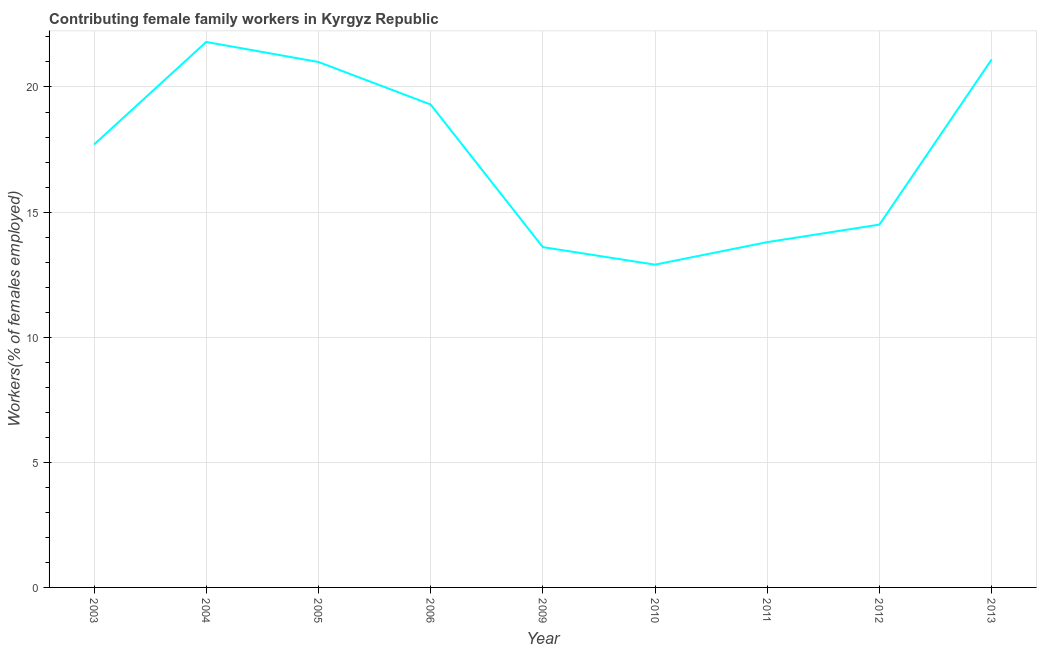What is the contributing female family workers in 2013?
Offer a terse response. 21.1. Across all years, what is the maximum contributing female family workers?
Keep it short and to the point. 21.8. Across all years, what is the minimum contributing female family workers?
Your answer should be very brief. 12.9. In which year was the contributing female family workers minimum?
Ensure brevity in your answer.  2010. What is the sum of the contributing female family workers?
Your answer should be very brief. 155.7. What is the difference between the contributing female family workers in 2006 and 2010?
Keep it short and to the point. 6.4. What is the average contributing female family workers per year?
Provide a succinct answer. 17.3. What is the median contributing female family workers?
Offer a terse response. 17.7. In how many years, is the contributing female family workers greater than 4 %?
Keep it short and to the point. 9. Do a majority of the years between 2012 and 2005 (inclusive) have contributing female family workers greater than 11 %?
Offer a very short reply. Yes. What is the ratio of the contributing female family workers in 2003 to that in 2005?
Offer a terse response. 0.84. Is the contributing female family workers in 2003 less than that in 2004?
Provide a short and direct response. Yes. What is the difference between the highest and the second highest contributing female family workers?
Make the answer very short. 0.7. Is the sum of the contributing female family workers in 2005 and 2010 greater than the maximum contributing female family workers across all years?
Provide a short and direct response. Yes. What is the difference between the highest and the lowest contributing female family workers?
Offer a terse response. 8.9. Does the contributing female family workers monotonically increase over the years?
Provide a succinct answer. No. How many years are there in the graph?
Provide a short and direct response. 9. Are the values on the major ticks of Y-axis written in scientific E-notation?
Offer a very short reply. No. Does the graph contain grids?
Ensure brevity in your answer.  Yes. What is the title of the graph?
Offer a very short reply. Contributing female family workers in Kyrgyz Republic. What is the label or title of the X-axis?
Give a very brief answer. Year. What is the label or title of the Y-axis?
Provide a succinct answer. Workers(% of females employed). What is the Workers(% of females employed) of 2003?
Provide a succinct answer. 17.7. What is the Workers(% of females employed) in 2004?
Offer a very short reply. 21.8. What is the Workers(% of females employed) of 2005?
Keep it short and to the point. 21. What is the Workers(% of females employed) of 2006?
Your answer should be very brief. 19.3. What is the Workers(% of females employed) of 2009?
Provide a short and direct response. 13.6. What is the Workers(% of females employed) in 2010?
Your answer should be compact. 12.9. What is the Workers(% of females employed) of 2011?
Give a very brief answer. 13.8. What is the Workers(% of females employed) in 2012?
Provide a succinct answer. 14.5. What is the Workers(% of females employed) of 2013?
Your answer should be very brief. 21.1. What is the difference between the Workers(% of females employed) in 2003 and 2004?
Offer a very short reply. -4.1. What is the difference between the Workers(% of females employed) in 2003 and 2005?
Provide a short and direct response. -3.3. What is the difference between the Workers(% of females employed) in 2003 and 2012?
Provide a short and direct response. 3.2. What is the difference between the Workers(% of females employed) in 2003 and 2013?
Offer a very short reply. -3.4. What is the difference between the Workers(% of females employed) in 2004 and 2005?
Provide a succinct answer. 0.8. What is the difference between the Workers(% of females employed) in 2004 and 2006?
Keep it short and to the point. 2.5. What is the difference between the Workers(% of females employed) in 2004 and 2009?
Provide a succinct answer. 8.2. What is the difference between the Workers(% of females employed) in 2004 and 2010?
Make the answer very short. 8.9. What is the difference between the Workers(% of females employed) in 2004 and 2011?
Offer a very short reply. 8. What is the difference between the Workers(% of females employed) in 2004 and 2013?
Offer a very short reply. 0.7. What is the difference between the Workers(% of females employed) in 2005 and 2006?
Provide a short and direct response. 1.7. What is the difference between the Workers(% of females employed) in 2005 and 2009?
Give a very brief answer. 7.4. What is the difference between the Workers(% of females employed) in 2005 and 2011?
Your response must be concise. 7.2. What is the difference between the Workers(% of females employed) in 2005 and 2012?
Your answer should be very brief. 6.5. What is the difference between the Workers(% of females employed) in 2006 and 2009?
Provide a succinct answer. 5.7. What is the difference between the Workers(% of females employed) in 2006 and 2011?
Your response must be concise. 5.5. What is the difference between the Workers(% of females employed) in 2006 and 2012?
Your response must be concise. 4.8. What is the difference between the Workers(% of females employed) in 2006 and 2013?
Ensure brevity in your answer.  -1.8. What is the difference between the Workers(% of females employed) in 2009 and 2011?
Give a very brief answer. -0.2. What is the difference between the Workers(% of females employed) in 2009 and 2012?
Offer a very short reply. -0.9. What is the difference between the Workers(% of females employed) in 2009 and 2013?
Your answer should be very brief. -7.5. What is the difference between the Workers(% of females employed) in 2010 and 2011?
Give a very brief answer. -0.9. What is the difference between the Workers(% of females employed) in 2010 and 2012?
Ensure brevity in your answer.  -1.6. What is the difference between the Workers(% of females employed) in 2010 and 2013?
Offer a very short reply. -8.2. What is the difference between the Workers(% of females employed) in 2011 and 2012?
Provide a short and direct response. -0.7. What is the difference between the Workers(% of females employed) in 2012 and 2013?
Your response must be concise. -6.6. What is the ratio of the Workers(% of females employed) in 2003 to that in 2004?
Make the answer very short. 0.81. What is the ratio of the Workers(% of females employed) in 2003 to that in 2005?
Keep it short and to the point. 0.84. What is the ratio of the Workers(% of females employed) in 2003 to that in 2006?
Keep it short and to the point. 0.92. What is the ratio of the Workers(% of females employed) in 2003 to that in 2009?
Make the answer very short. 1.3. What is the ratio of the Workers(% of females employed) in 2003 to that in 2010?
Your answer should be compact. 1.37. What is the ratio of the Workers(% of females employed) in 2003 to that in 2011?
Offer a terse response. 1.28. What is the ratio of the Workers(% of females employed) in 2003 to that in 2012?
Offer a terse response. 1.22. What is the ratio of the Workers(% of females employed) in 2003 to that in 2013?
Your response must be concise. 0.84. What is the ratio of the Workers(% of females employed) in 2004 to that in 2005?
Your response must be concise. 1.04. What is the ratio of the Workers(% of females employed) in 2004 to that in 2006?
Offer a terse response. 1.13. What is the ratio of the Workers(% of females employed) in 2004 to that in 2009?
Your answer should be compact. 1.6. What is the ratio of the Workers(% of females employed) in 2004 to that in 2010?
Provide a succinct answer. 1.69. What is the ratio of the Workers(% of females employed) in 2004 to that in 2011?
Your answer should be compact. 1.58. What is the ratio of the Workers(% of females employed) in 2004 to that in 2012?
Your response must be concise. 1.5. What is the ratio of the Workers(% of females employed) in 2004 to that in 2013?
Ensure brevity in your answer.  1.03. What is the ratio of the Workers(% of females employed) in 2005 to that in 2006?
Offer a terse response. 1.09. What is the ratio of the Workers(% of females employed) in 2005 to that in 2009?
Give a very brief answer. 1.54. What is the ratio of the Workers(% of females employed) in 2005 to that in 2010?
Your answer should be very brief. 1.63. What is the ratio of the Workers(% of females employed) in 2005 to that in 2011?
Give a very brief answer. 1.52. What is the ratio of the Workers(% of females employed) in 2005 to that in 2012?
Your answer should be very brief. 1.45. What is the ratio of the Workers(% of females employed) in 2006 to that in 2009?
Give a very brief answer. 1.42. What is the ratio of the Workers(% of females employed) in 2006 to that in 2010?
Your response must be concise. 1.5. What is the ratio of the Workers(% of females employed) in 2006 to that in 2011?
Your answer should be very brief. 1.4. What is the ratio of the Workers(% of females employed) in 2006 to that in 2012?
Give a very brief answer. 1.33. What is the ratio of the Workers(% of females employed) in 2006 to that in 2013?
Provide a succinct answer. 0.92. What is the ratio of the Workers(% of females employed) in 2009 to that in 2010?
Keep it short and to the point. 1.05. What is the ratio of the Workers(% of females employed) in 2009 to that in 2011?
Your answer should be compact. 0.99. What is the ratio of the Workers(% of females employed) in 2009 to that in 2012?
Keep it short and to the point. 0.94. What is the ratio of the Workers(% of females employed) in 2009 to that in 2013?
Your answer should be very brief. 0.65. What is the ratio of the Workers(% of females employed) in 2010 to that in 2011?
Provide a succinct answer. 0.94. What is the ratio of the Workers(% of females employed) in 2010 to that in 2012?
Give a very brief answer. 0.89. What is the ratio of the Workers(% of females employed) in 2010 to that in 2013?
Your response must be concise. 0.61. What is the ratio of the Workers(% of females employed) in 2011 to that in 2012?
Offer a terse response. 0.95. What is the ratio of the Workers(% of females employed) in 2011 to that in 2013?
Make the answer very short. 0.65. What is the ratio of the Workers(% of females employed) in 2012 to that in 2013?
Offer a terse response. 0.69. 